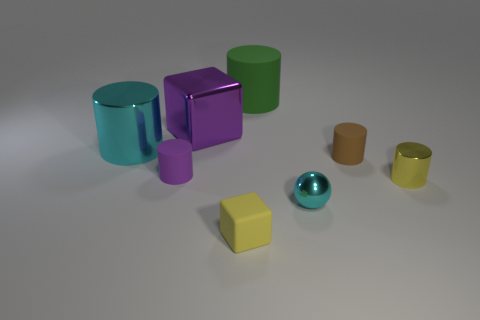There is a cylinder that is the same color as the large cube; what size is it?
Provide a short and direct response. Small. There is a large metal thing that is on the right side of the tiny rubber cylinder to the left of the large rubber cylinder; what shape is it?
Provide a short and direct response. Cube. There is a green rubber object; does it have the same shape as the yellow object right of the metal ball?
Ensure brevity in your answer.  Yes. There is a metallic cylinder to the right of the tiny yellow block; what number of yellow objects are behind it?
Your answer should be compact. 0. What is the material of the tiny brown thing that is the same shape as the tiny purple matte object?
Make the answer very short. Rubber. How many yellow things are either big metal blocks or small metallic things?
Give a very brief answer. 1. Is there anything else that has the same color as the tiny metallic cylinder?
Keep it short and to the point. Yes. What is the color of the rubber thing in front of the cyan shiny thing that is in front of the tiny yellow metallic object?
Give a very brief answer. Yellow. Is the number of big cyan cylinders that are behind the green rubber thing less than the number of large cyan objects that are on the right side of the shiny ball?
Provide a short and direct response. No. There is a cylinder that is the same color as the tiny shiny sphere; what material is it?
Provide a succinct answer. Metal. 